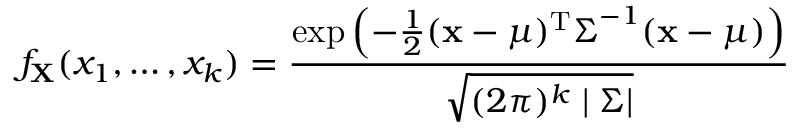<formula> <loc_0><loc_0><loc_500><loc_500>f _ { X } ( x _ { 1 } , \dots , x _ { k } ) = { \frac { \exp \left ( - { \frac { 1 } { 2 } } ( { x } - { \mu } ) ^ { T } { \Sigma } ^ { - 1 } ( { x } - { \mu } ) \right ) } { \sqrt { ( 2 \pi ) ^ { k } | { \Sigma } | } } }</formula> 